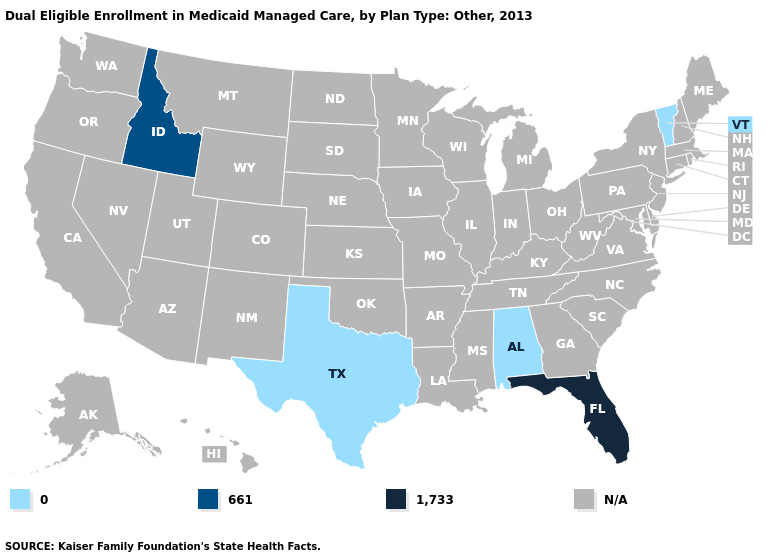Which states have the highest value in the USA?
Short answer required. Florida. What is the value of Illinois?
Quick response, please. N/A. Does Idaho have the lowest value in the USA?
Keep it brief. No. Name the states that have a value in the range 1,733?
Write a very short answer. Florida. What is the value of Hawaii?
Give a very brief answer. N/A. Name the states that have a value in the range N/A?
Give a very brief answer. Alaska, Arizona, Arkansas, California, Colorado, Connecticut, Delaware, Georgia, Hawaii, Illinois, Indiana, Iowa, Kansas, Kentucky, Louisiana, Maine, Maryland, Massachusetts, Michigan, Minnesota, Mississippi, Missouri, Montana, Nebraska, Nevada, New Hampshire, New Jersey, New Mexico, New York, North Carolina, North Dakota, Ohio, Oklahoma, Oregon, Pennsylvania, Rhode Island, South Carolina, South Dakota, Tennessee, Utah, Virginia, Washington, West Virginia, Wisconsin, Wyoming. Name the states that have a value in the range 0?
Answer briefly. Alabama, Texas, Vermont. Among the states that border New York , which have the lowest value?
Answer briefly. Vermont. Name the states that have a value in the range 1,733?
Concise answer only. Florida. Which states have the lowest value in the USA?
Give a very brief answer. Alabama, Texas, Vermont. 